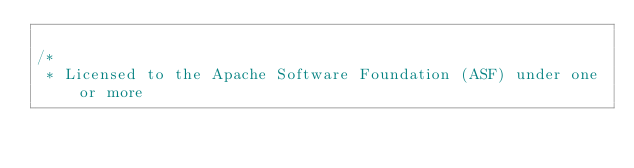Convert code to text. <code><loc_0><loc_0><loc_500><loc_500><_C#_>
/*
 * Licensed to the Apache Software Foundation (ASF) under one or more</code> 